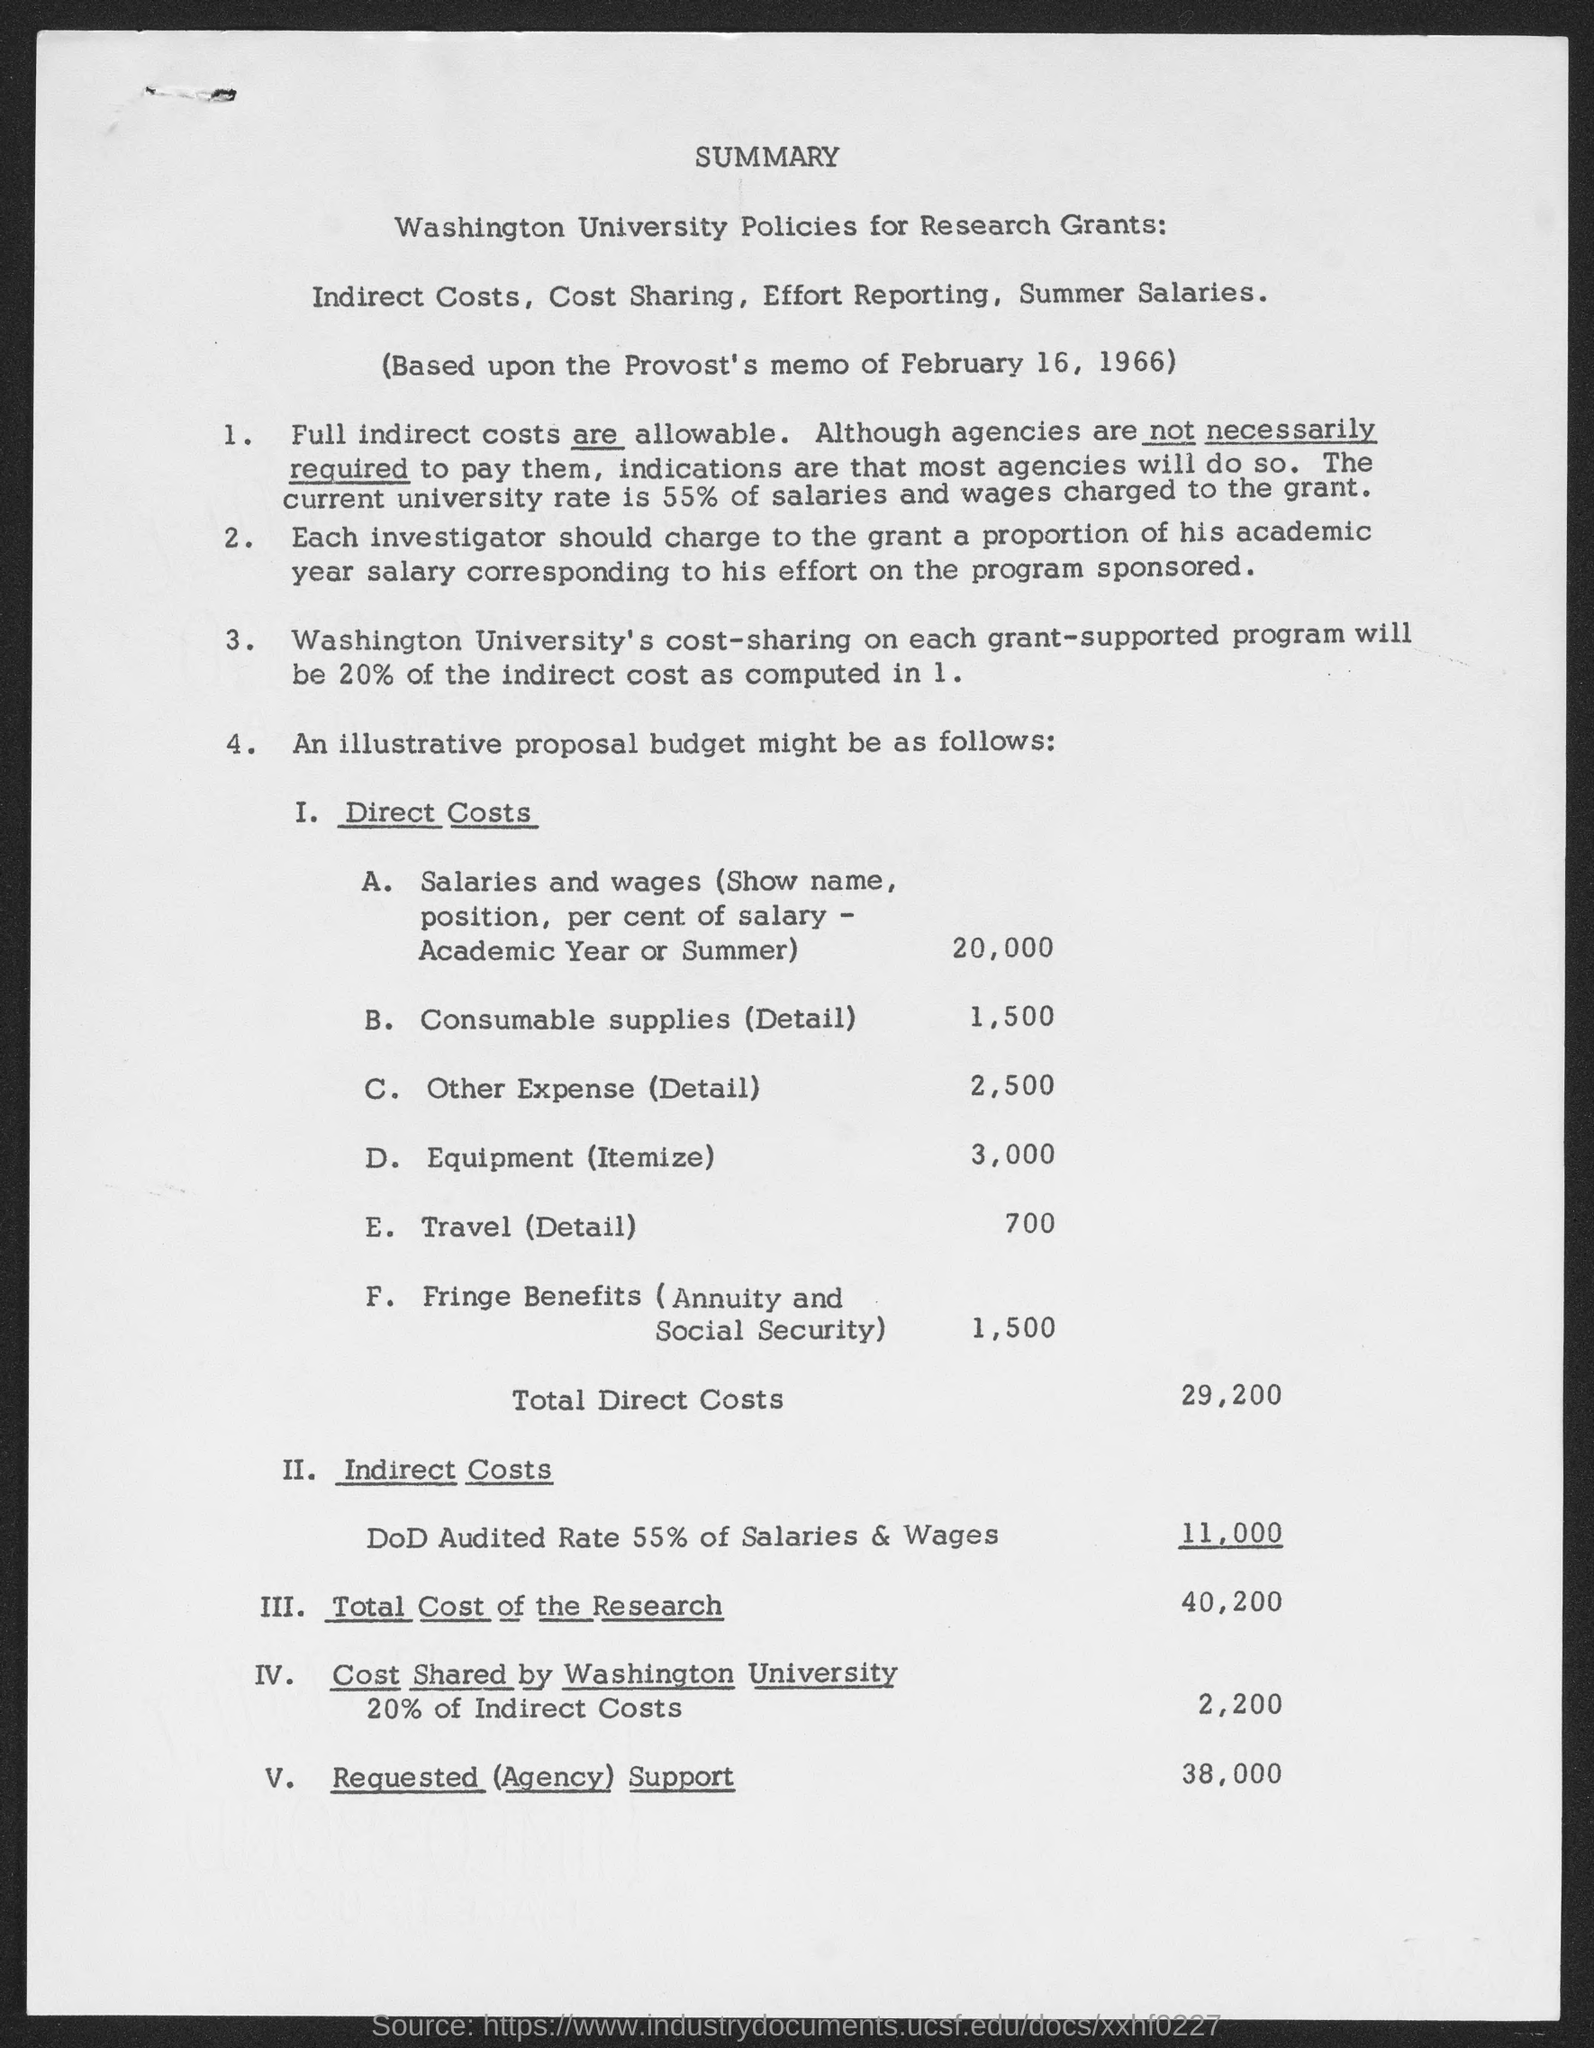Highlight a few significant elements in this photo. The requested support from the agency is 38,000... The total direct costs are $29,200. The total cost of the research is $40,200. 